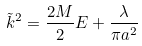<formula> <loc_0><loc_0><loc_500><loc_500>\tilde { k } ^ { 2 } = \frac { 2 M } { 2 } E + \frac { \lambda } { \pi a ^ { 2 } }</formula> 